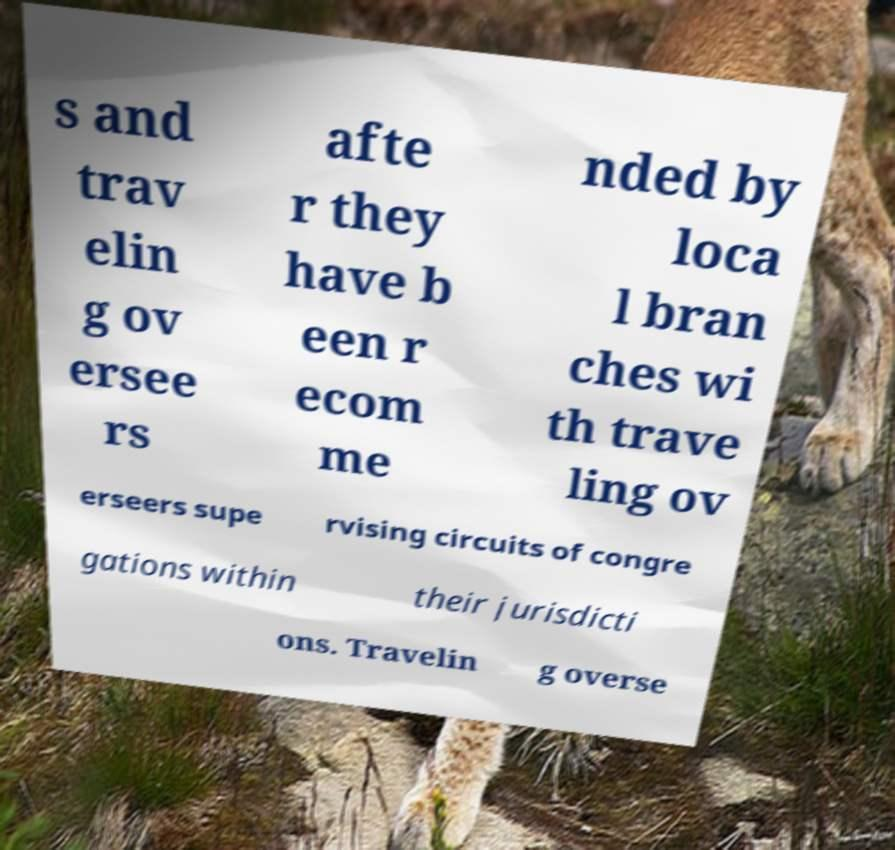I need the written content from this picture converted into text. Can you do that? s and trav elin g ov ersee rs afte r they have b een r ecom me nded by loca l bran ches wi th trave ling ov erseers supe rvising circuits of congre gations within their jurisdicti ons. Travelin g overse 